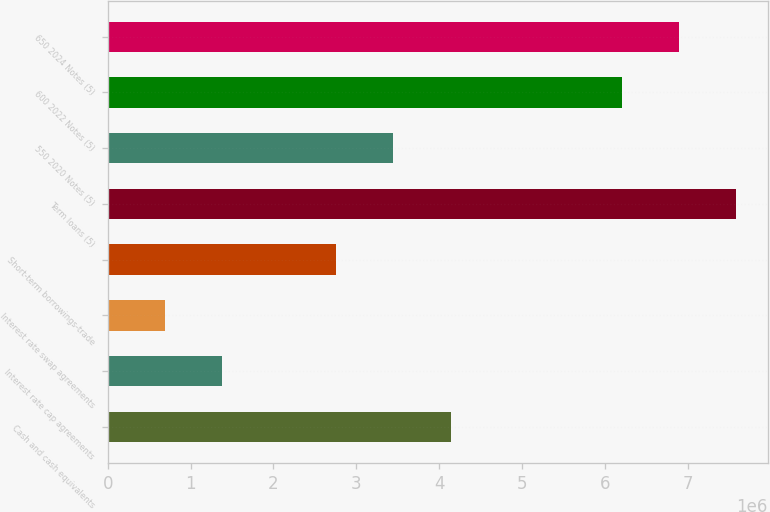<chart> <loc_0><loc_0><loc_500><loc_500><bar_chart><fcel>Cash and cash equivalents<fcel>Interest rate cap agreements<fcel>Interest rate swap agreements<fcel>Short-term borrowings-trade<fcel>Term loans (5)<fcel>550 2020 Notes (5)<fcel>600 2022 Notes (5)<fcel>650 2024 Notes (5)<nl><fcel>4.13514e+06<fcel>1.38032e+06<fcel>691610<fcel>2.75773e+06<fcel>7.57866e+06<fcel>3.44643e+06<fcel>6.20125e+06<fcel>6.88996e+06<nl></chart> 